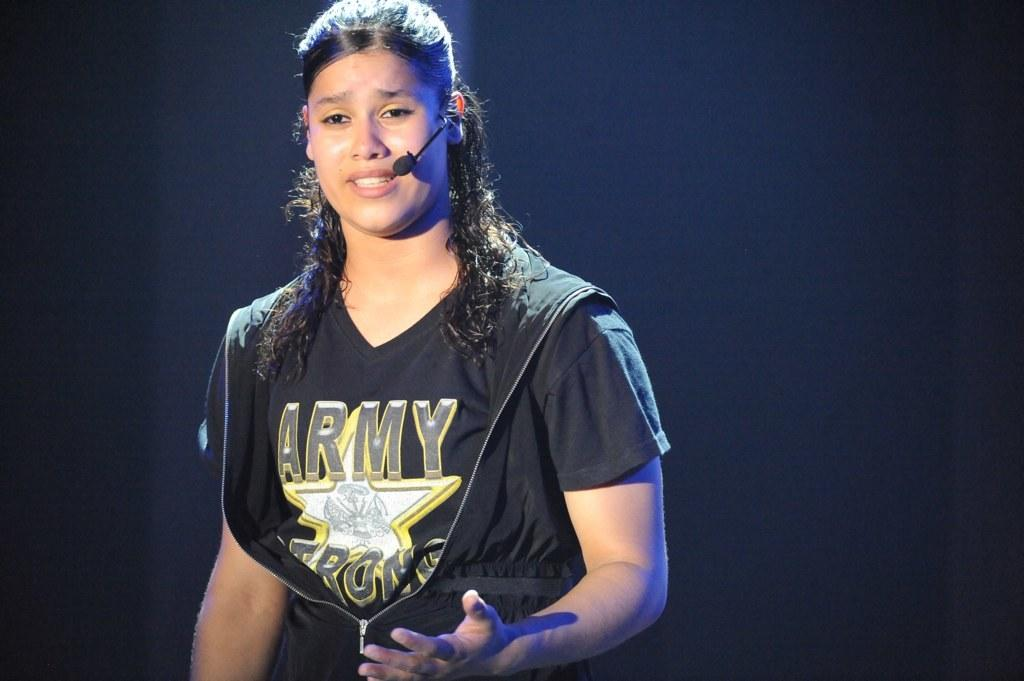Provide a one-sentence caption for the provided image. A lady with a microphone is wearing a black Army Strong t-shirt. 